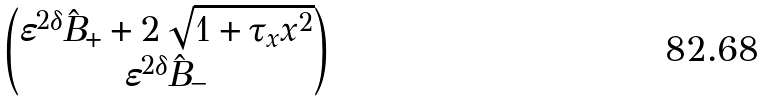<formula> <loc_0><loc_0><loc_500><loc_500>\begin{pmatrix} \varepsilon ^ { 2 \delta } \hat { B } _ { + } + 2 \sqrt { 1 + \tau _ { x } x ^ { 2 } } \\ \varepsilon ^ { 2 \delta } \hat { B } _ { - } \end{pmatrix}</formula> 